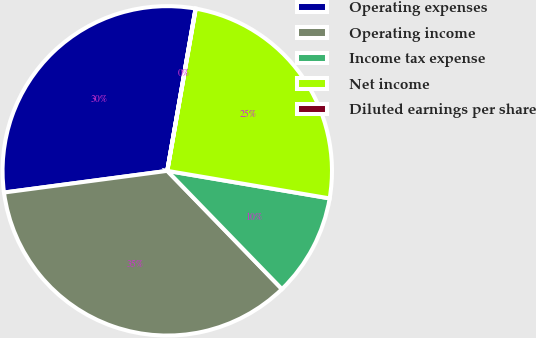<chart> <loc_0><loc_0><loc_500><loc_500><pie_chart><fcel>Operating expenses<fcel>Operating income<fcel>Income tax expense<fcel>Net income<fcel>Diluted earnings per share<nl><fcel>29.85%<fcel>35.16%<fcel>10.07%<fcel>24.91%<fcel>0.02%<nl></chart> 